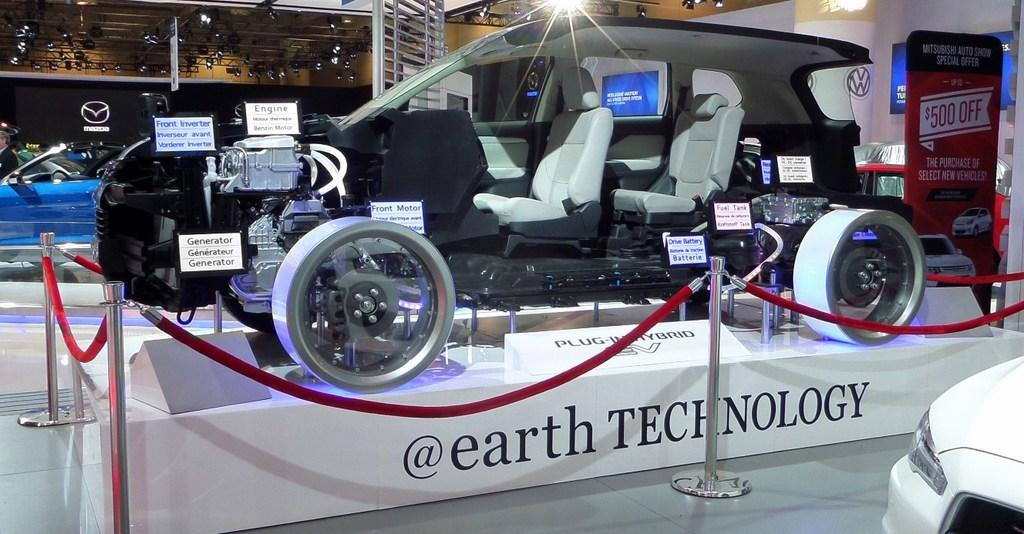What type of objects are present in the image? There are vehicles in the image. Can you describe the color of one of the vehicles? One of the vehicles is black. What part of a vehicle can be seen in the image? The inner part of a vehicle is visible. What can be seen in the background of the image? There is railing and lights in the background of the image. Can you tell me how many cacti are present in the image? There are no cacti present in the image; it features vehicles and their surroundings. 